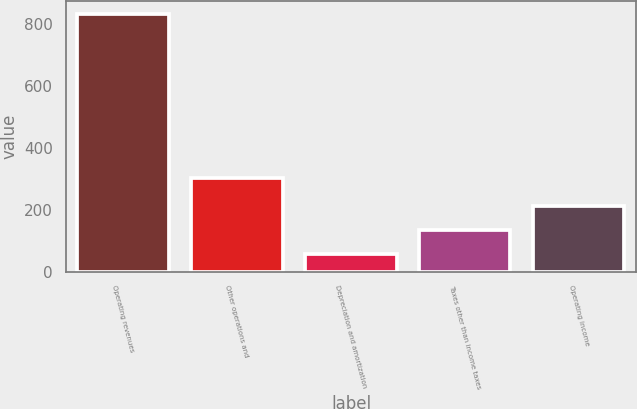Convert chart to OTSL. <chart><loc_0><loc_0><loc_500><loc_500><bar_chart><fcel>Operating revenues<fcel>Other operations and<fcel>Depreciation and amortization<fcel>Taxes other than income taxes<fcel>Operating income<nl><fcel>833<fcel>302<fcel>56<fcel>133.7<fcel>211.4<nl></chart> 